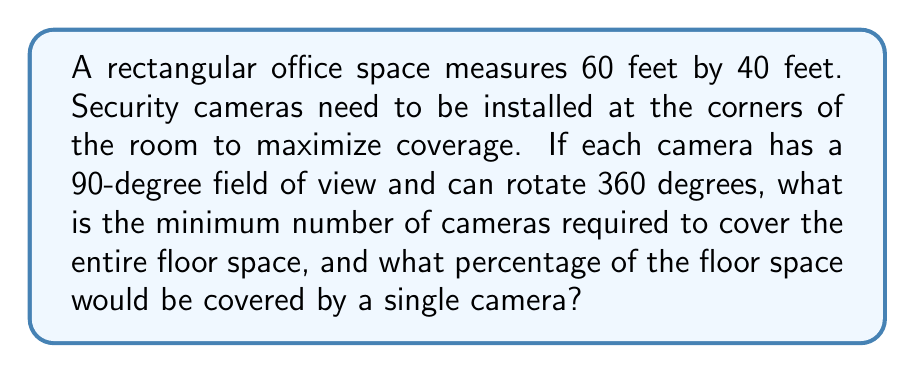Help me with this question. Let's approach this step-by-step:

1) First, we need to calculate the total area of the office space:
   Area = length × width
   $A = 60 \text{ ft} \times 40 \text{ ft} = 2400 \text{ sq ft}$

2) A camera with a 90-degree field of view placed in a corner will cover a quarter-circle area. The radius of this quarter-circle will be the length of the room's diagonal.

3) To calculate the diagonal:
   $d = \sqrt{60^2 + 40^2} = \sqrt{3600 + 1600} = \sqrt{5200} \approx 72.11 \text{ ft}$

4) The area covered by one camera is:
   $A_{\text{camera}} = \frac{1}{4} \pi r^2 = \frac{1}{4} \pi (72.11)^2 \approx 1629.92 \text{ sq ft}$

5) Percentage of floor space covered by one camera:
   $\frac{1629.92}{2400} \times 100\% \approx 67.91\%$

6) To cover the entire space, we need cameras in at least two opposite corners. This will ensure full coverage with some overlap.

[asy]
import geometry;

size(200);
draw((0,0)--(60,0)--(60,40)--(0,40)--cycle);
draw(arc((0,0),72.11,0,90), blue);
draw(arc((60,40),72.11,180,270), red);
label("60 ft", (30,0), S);
label("40 ft", (60,20), E);
dot((0,0));
dot((60,40));
label("Camera 1", (0,0), SW);
label("Camera 2", (60,40), NE);
[/asy]
Answer: 2 cameras; 67.91% 